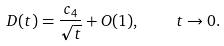<formula> <loc_0><loc_0><loc_500><loc_500>D ( t ) = \frac { c _ { 4 } } { \sqrt { t } } + O ( 1 ) , \quad t \rightarrow 0 .</formula> 